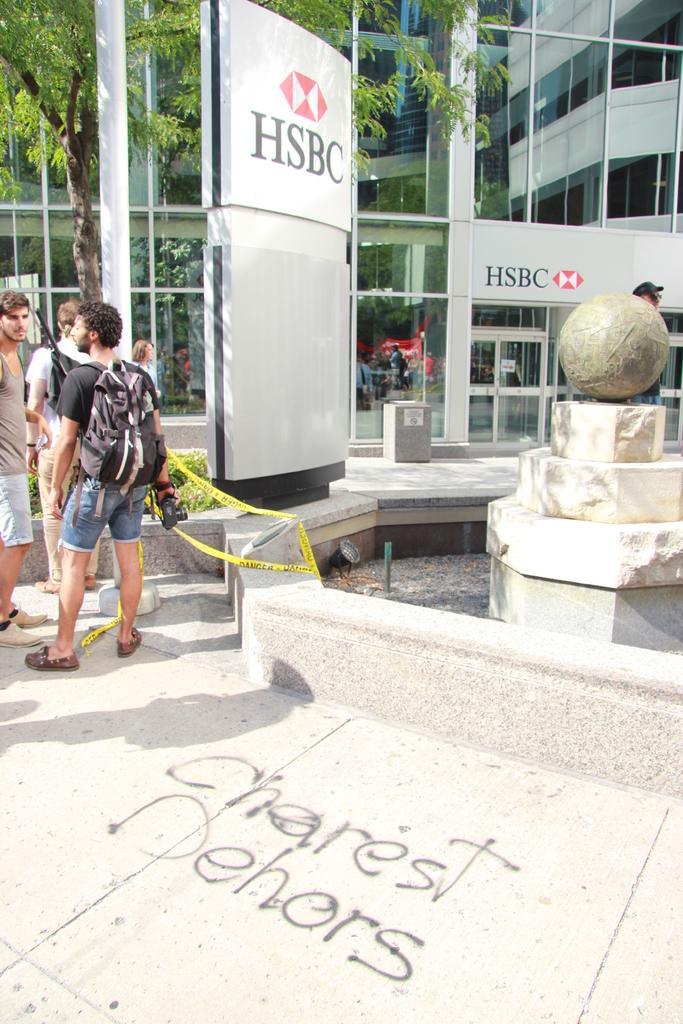How would you summarize this image in a sentence or two? In this image we can see the persons. Beside the persons we can see a fountain and a board with text. Behind the persons we can see the plants, a pole, tree and a building. On the building we can see the glasses. 